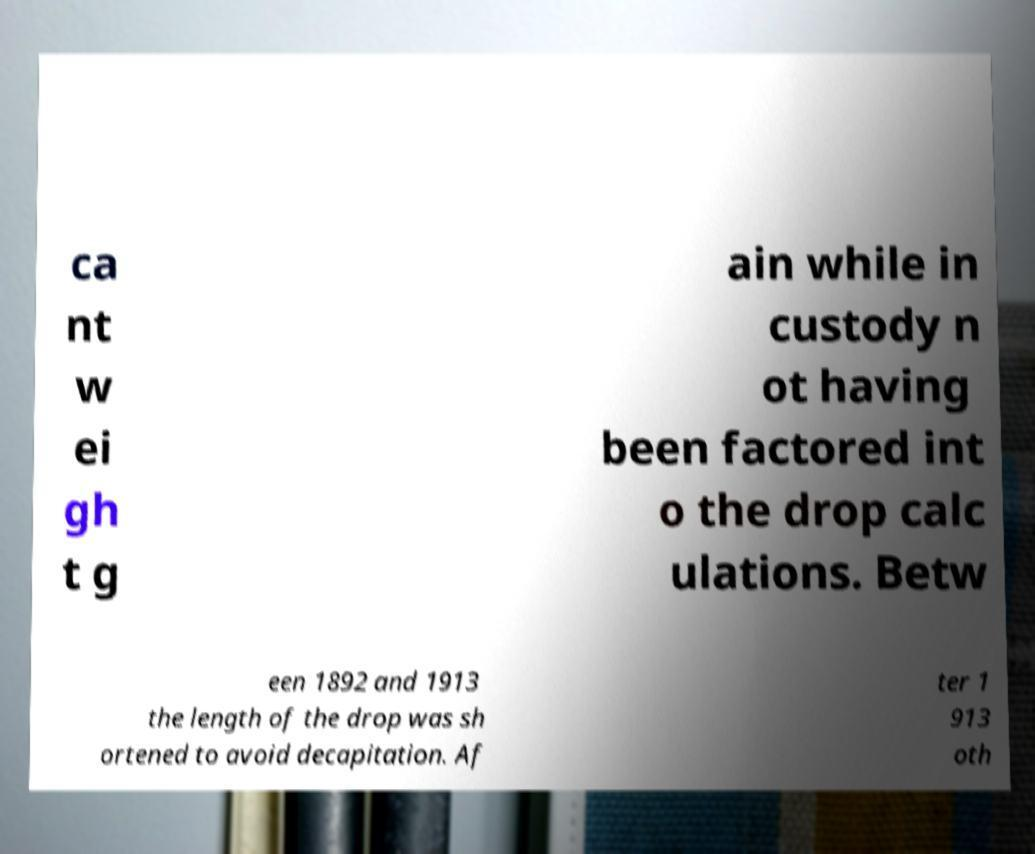Could you assist in decoding the text presented in this image and type it out clearly? ca nt w ei gh t g ain while in custody n ot having been factored int o the drop calc ulations. Betw een 1892 and 1913 the length of the drop was sh ortened to avoid decapitation. Af ter 1 913 oth 